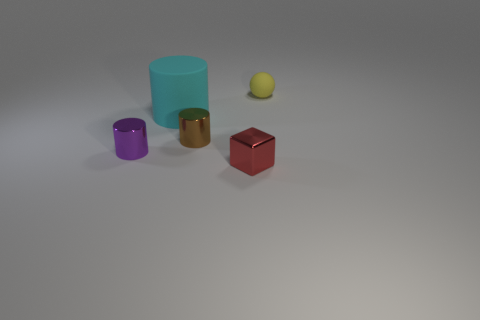What materials do the objects in the image appear to be made of? The objects in the image appear to be made from various materials. The small and large cylinders look like they are constructed from a matte-finished metal. The small block has a glossy surface, suggesting it could be either a polished metal or plastic. Lastly, the sphere has a slightly textured surface, which might indicate a rubber or matte plastic material. 